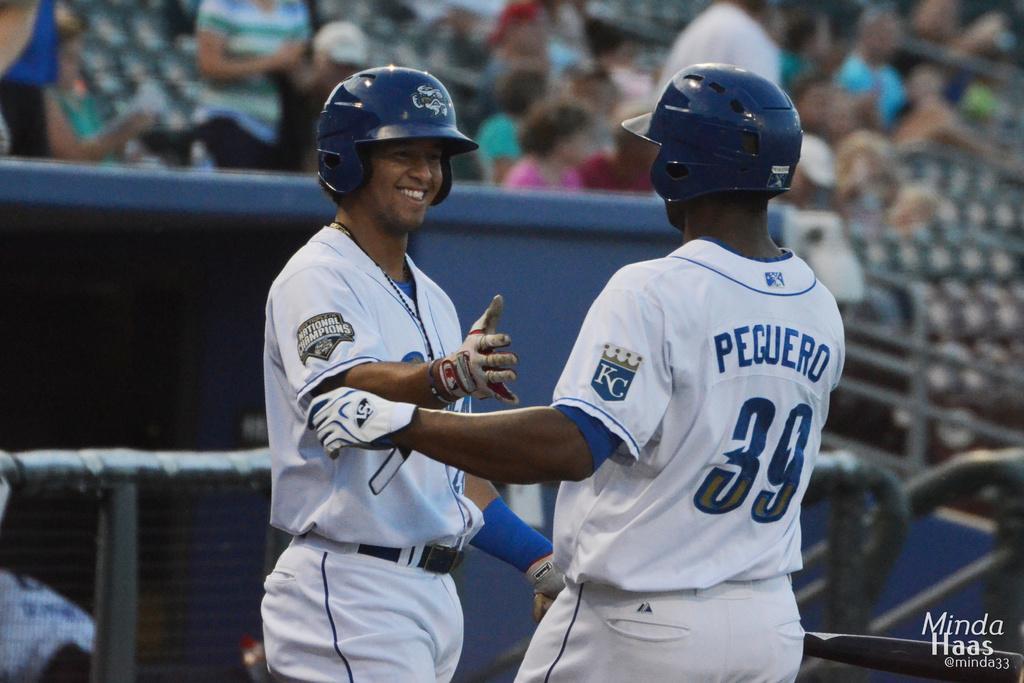How would you summarize this image in a sentence or two? In this image we can see two men standing. On the backside we can see a fence, a group of people and some empty chairs. 